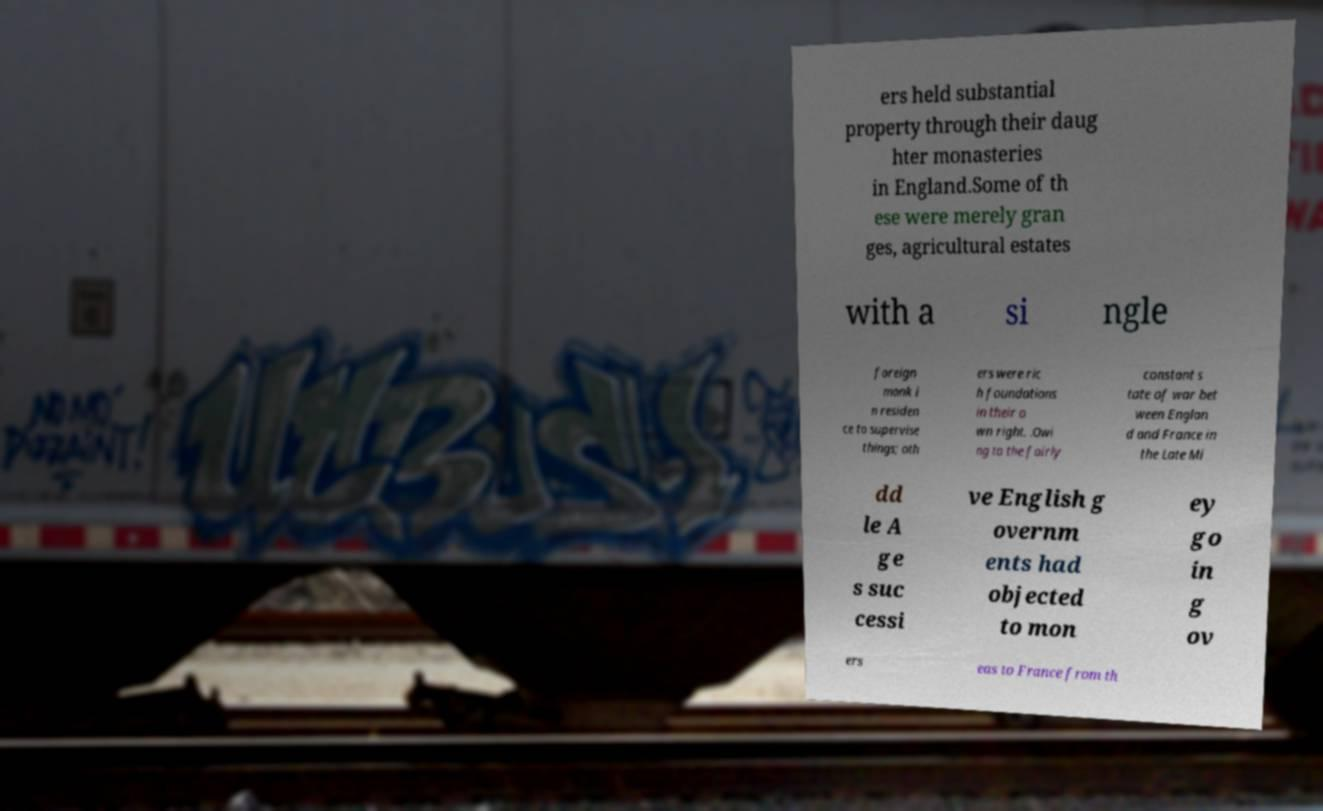I need the written content from this picture converted into text. Can you do that? ers held substantial property through their daug hter monasteries in England.Some of th ese were merely gran ges, agricultural estates with a si ngle foreign monk i n residen ce to supervise things; oth ers were ric h foundations in their o wn right. .Owi ng to the fairly constant s tate of war bet ween Englan d and France in the Late Mi dd le A ge s suc cessi ve English g overnm ents had objected to mon ey go in g ov ers eas to France from th 